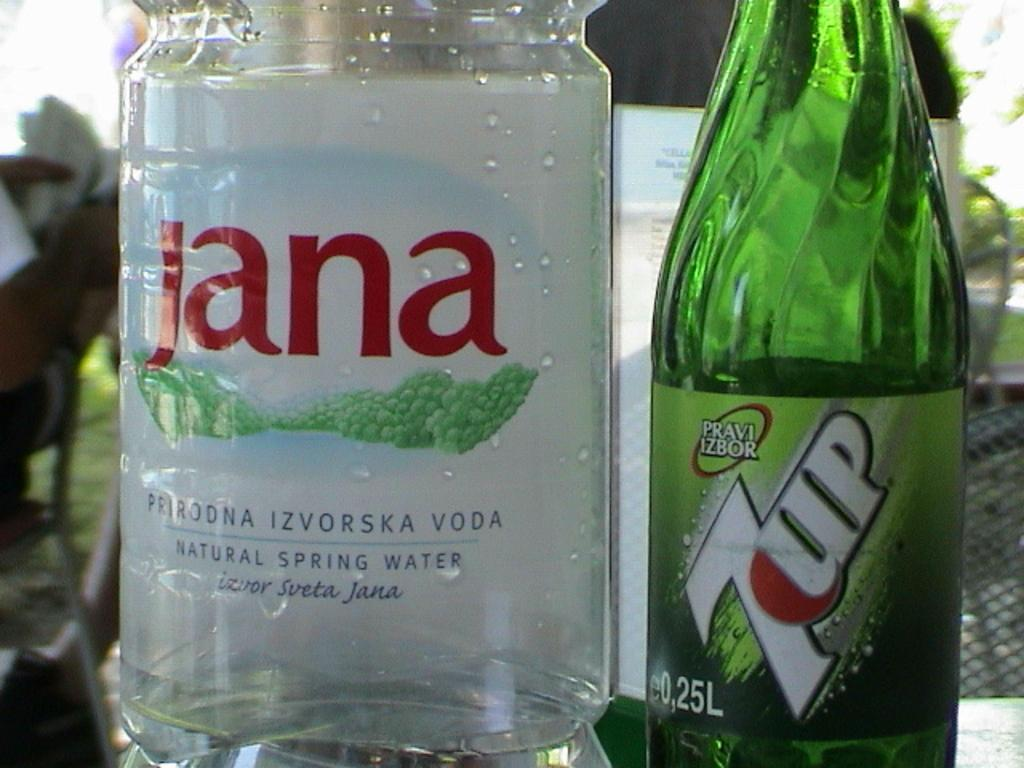Provide a one-sentence caption for the provided image. Deciding on whether to drink spring water or a 7UP. 